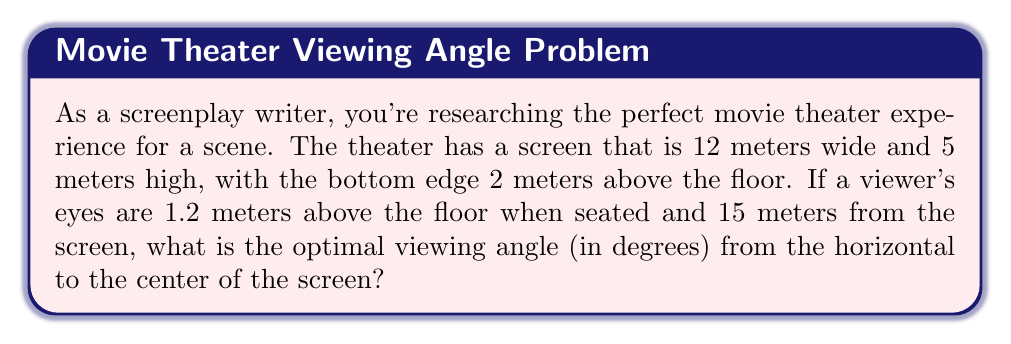Help me with this question. Let's approach this step-by-step:

1) First, we need to find the height of the center of the screen from the floor:
   Bottom of screen = 2 m
   Height of screen = 5 m
   Center height = 2 + (5/2) = 4.5 m

2) Now, we can calculate the vertical distance from the viewer's eyes to the center of the screen:
   Vertical distance = 4.5 m - 1.2 m = 3.3 m

3) We know the horizontal distance to the screen is 15 m.

4) We can now use the arctangent function to find the angle:

   $$\theta = \arctan(\frac{\text{opposite}}{\text{adjacent}})$$

   $$\theta = \arctan(\frac{3.3}{15})$$

5) Calculate this value:
   $$\theta = \arctan(0.22)$$
   $$\theta \approx 12.41^\circ$$

[asy]
import geometry;

size(200);
pair A = (0,0), B = (15,0), C = (15,3.3);
draw(A--B--C--A);
label("15 m", (7.5,-0.5));
label("3.3 m", (15.5,1.65));
label("θ", (1,0.5));
dot("Viewer", A, SW);
dot("Screen Center", C, E);
[/asy]
Answer: $12.41^\circ$ 